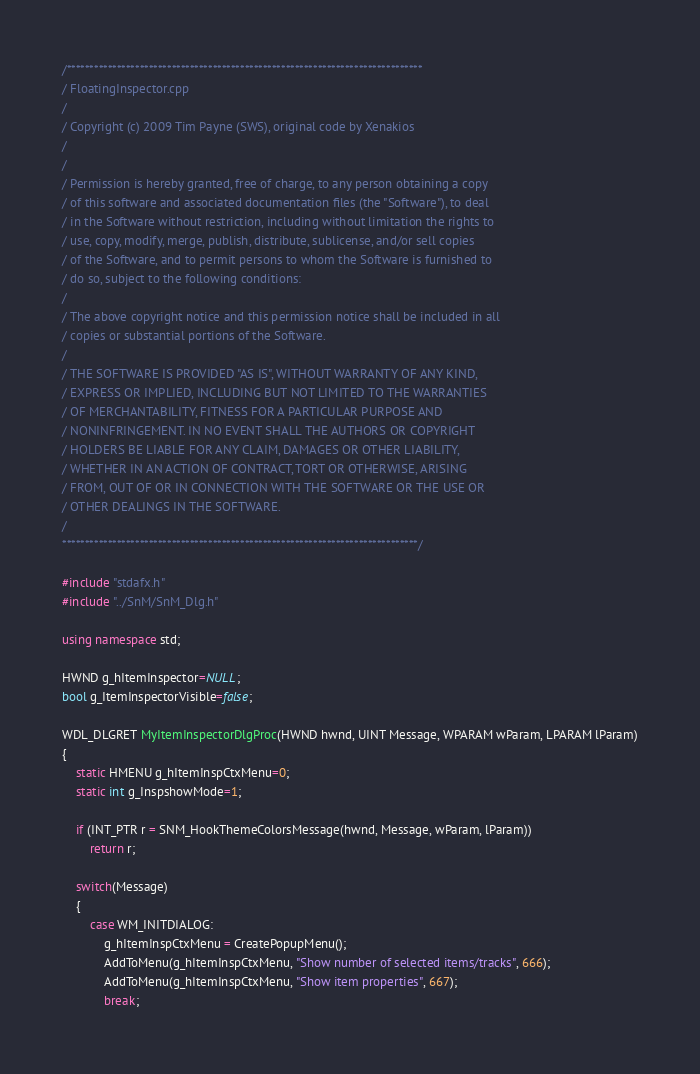Convert code to text. <code><loc_0><loc_0><loc_500><loc_500><_C++_>/******************************************************************************
/ FloatingInspector.cpp
/
/ Copyright (c) 2009 Tim Payne (SWS), original code by Xenakios
/
/
/ Permission is hereby granted, free of charge, to any person obtaining a copy
/ of this software and associated documentation files (the "Software"), to deal
/ in the Software without restriction, including without limitation the rights to
/ use, copy, modify, merge, publish, distribute, sublicense, and/or sell copies
/ of the Software, and to permit persons to whom the Software is furnished to
/ do so, subject to the following conditions:
/ 
/ The above copyright notice and this permission notice shall be included in all
/ copies or substantial portions of the Software.
/ 
/ THE SOFTWARE IS PROVIDED "AS IS", WITHOUT WARRANTY OF ANY KIND,
/ EXPRESS OR IMPLIED, INCLUDING BUT NOT LIMITED TO THE WARRANTIES
/ OF MERCHANTABILITY, FITNESS FOR A PARTICULAR PURPOSE AND
/ NONINFRINGEMENT. IN NO EVENT SHALL THE AUTHORS OR COPYRIGHT
/ HOLDERS BE LIABLE FOR ANY CLAIM, DAMAGES OR OTHER LIABILITY,
/ WHETHER IN AN ACTION OF CONTRACT, TORT OR OTHERWISE, ARISING
/ FROM, OUT OF OR IN CONNECTION WITH THE SOFTWARE OR THE USE OR
/ OTHER DEALINGS IN THE SOFTWARE.
/
******************************************************************************/

#include "stdafx.h"
#include "../SnM/SnM_Dlg.h"

using namespace std;

HWND g_hItemInspector=NULL;
bool g_ItemInspectorVisible=false;

WDL_DLGRET MyItemInspectorDlgProc(HWND hwnd, UINT Message, WPARAM wParam, LPARAM lParam)
{
	static HMENU g_hItemInspCtxMenu=0;
	static int g_InspshowMode=1;
	
	if (INT_PTR r = SNM_HookThemeColorsMessage(hwnd, Message, wParam, lParam))
		return r;
	
	switch(Message)
    {
        case WM_INITDIALOG:
			g_hItemInspCtxMenu = CreatePopupMenu();
			AddToMenu(g_hItemInspCtxMenu, "Show number of selected items/tracks", 666);
			AddToMenu(g_hItemInspCtxMenu, "Show item properties", 667);
			break;</code> 